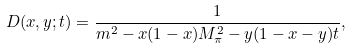Convert formula to latex. <formula><loc_0><loc_0><loc_500><loc_500>D ( x , y ; t ) = \frac { 1 } { m ^ { 2 } - x ( 1 - x ) M ^ { 2 } _ { \pi } - y ( 1 - x - y ) t } ,</formula> 